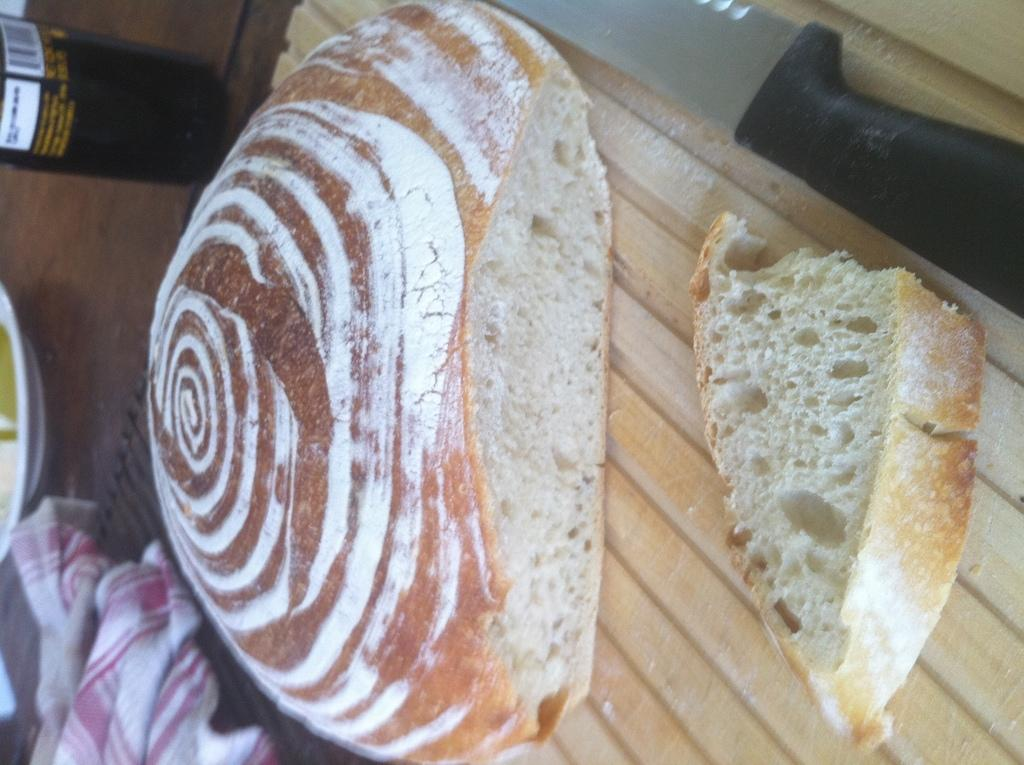What type of food item is visible in the image? There is a bread in the image. Where is the bread located in the image? The bread is placed on a table. What other objects can be seen on the table in the image? There is a glass bottle, pink and white cloth, and a plate placed on the table in the image. What type of milk is being served at the party in the image? There is no party or milk present in the image; it only shows a bread, glass bottle, pink and white cloth, and a plate on a table. 